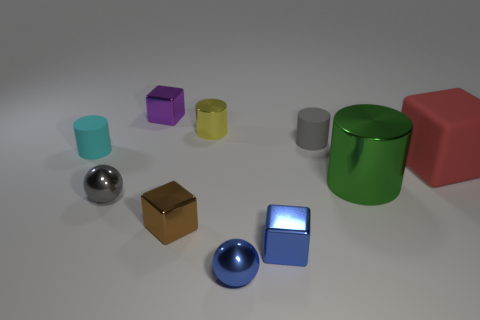What is the size of the metal ball that is behind the metal ball that is in front of the tiny shiny thing left of the tiny purple metallic object?
Make the answer very short. Small. Are there fewer small metallic objects that are in front of the big cube than tiny gray cylinders left of the yellow object?
Give a very brief answer. No. What number of cylinders have the same material as the big green thing?
Keep it short and to the point. 1. Is there a gray object that is behind the matte cylinder that is to the left of the gray object on the right side of the gray metal sphere?
Keep it short and to the point. Yes. What shape is the gray thing that is made of the same material as the tiny purple thing?
Offer a terse response. Sphere. Are there more big blue balls than blue spheres?
Ensure brevity in your answer.  No. Does the gray matte thing have the same shape as the rubber thing left of the tiny metal cylinder?
Make the answer very short. Yes. What is the material of the blue sphere?
Your response must be concise. Metal. There is a sphere on the right side of the tiny block that is behind the rubber cylinder right of the tiny cyan matte thing; what color is it?
Make the answer very short. Blue. What is the material of the red object that is the same shape as the brown thing?
Make the answer very short. Rubber. 